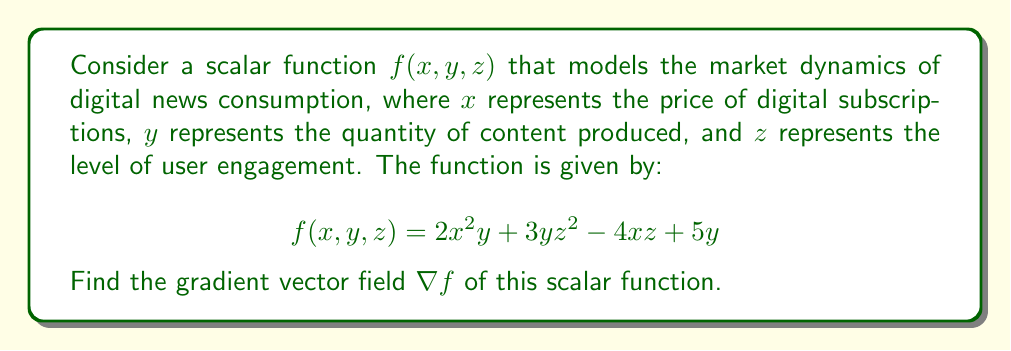Teach me how to tackle this problem. To find the gradient vector field of the scalar function $f(x, y, z)$, we need to calculate the partial derivatives of $f$ with respect to each variable $x$, $y$, and $z$. The gradient is then expressed as a vector of these partial derivatives.

The gradient is defined as:

$$\nabla f = \left(\frac{\partial f}{\partial x}, \frac{\partial f}{\partial y}, \frac{\partial f}{\partial z}\right)$$

Let's calculate each partial derivative:

1. $\frac{\partial f}{\partial x}$:
   $$\frac{\partial f}{\partial x} = \frac{\partial}{\partial x}(2x^2y + 3yz^2 - 4xz + 5y) = 4xy - 4z$$

2. $\frac{\partial f}{\partial y}$:
   $$\frac{\partial f}{\partial y} = \frac{\partial}{\partial y}(2x^2y + 3yz^2 - 4xz + 5y) = 2x^2 + 3z^2 + 5$$

3. $\frac{\partial f}{\partial z}$:
   $$\frac{\partial f}{\partial z} = \frac{\partial}{\partial z}(2x^2y + 3yz^2 - 4xz + 5y) = 6yz - 4x$$

Now, we can combine these partial derivatives to form the gradient vector field:

$$\nabla f = (4xy - 4z, 2x^2 + 3z^2 + 5, 6yz - 4x)$$

This gradient vector field describes the direction and magnitude of the steepest increase in the market dynamics function at any given point $(x, y, z)$ in the domain.
Answer: $$\nabla f = (4xy - 4z, 2x^2 + 3z^2 + 5, 6yz - 4x)$$ 